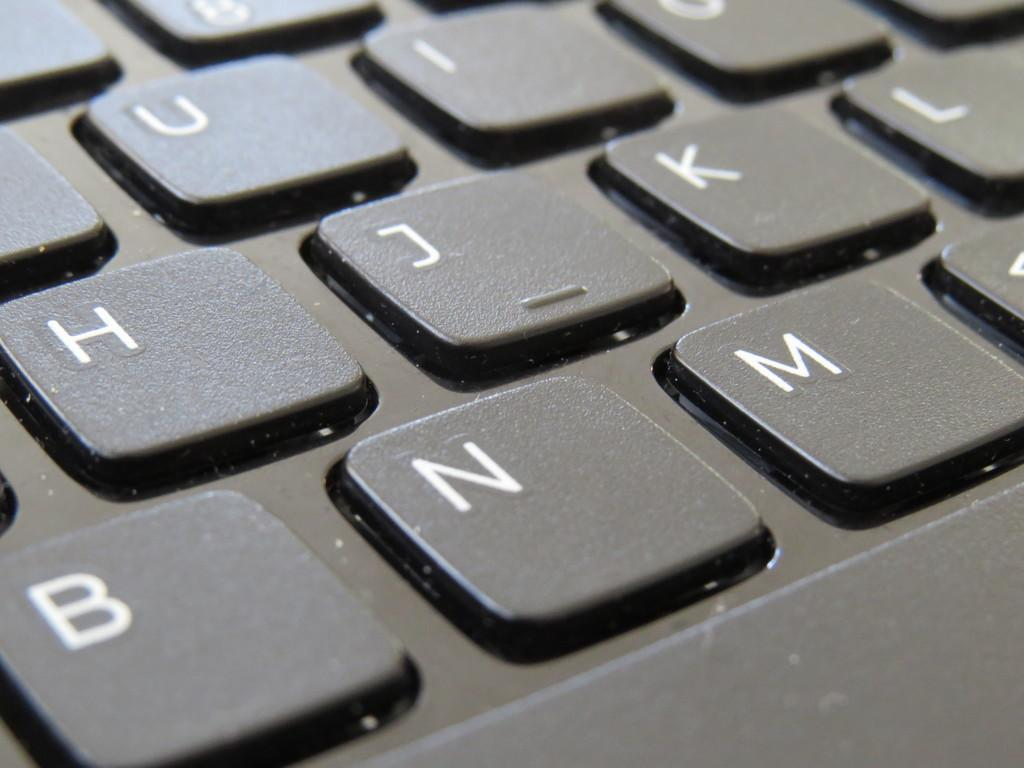<image>
Present a compact description of the photo's key features. A keyboard has white letters and the letter J key has a small horizontal like on it. 